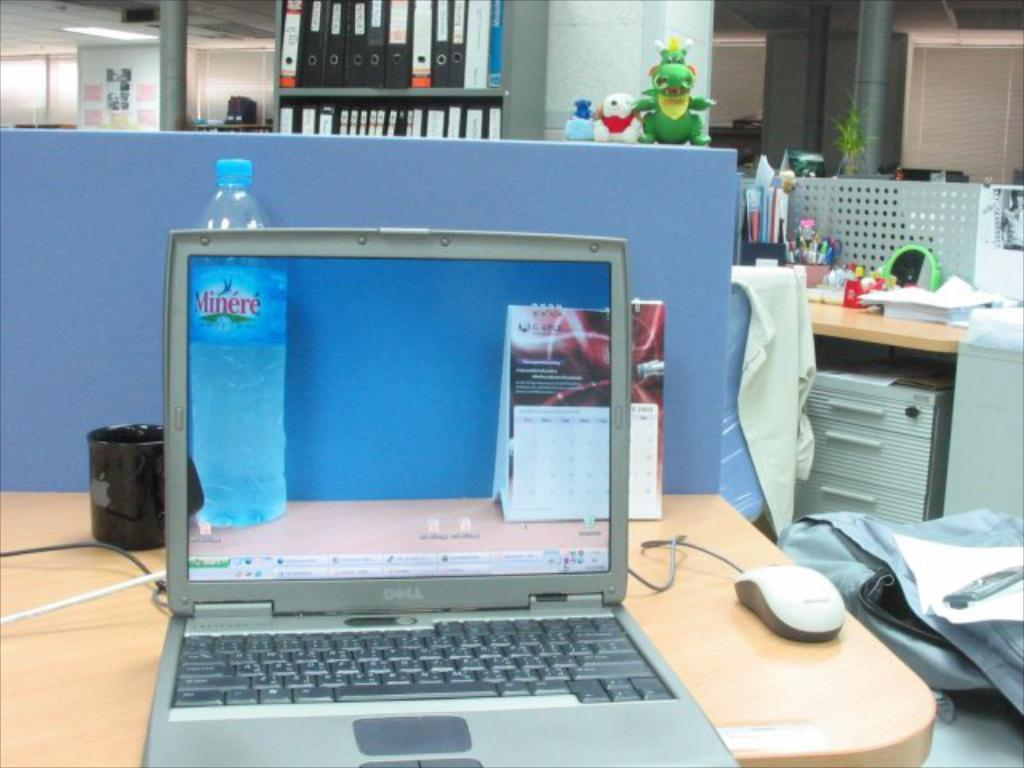<image>
Provide a brief description of the given image. A laptop taking a picture of a desk with a Minere water bottle 